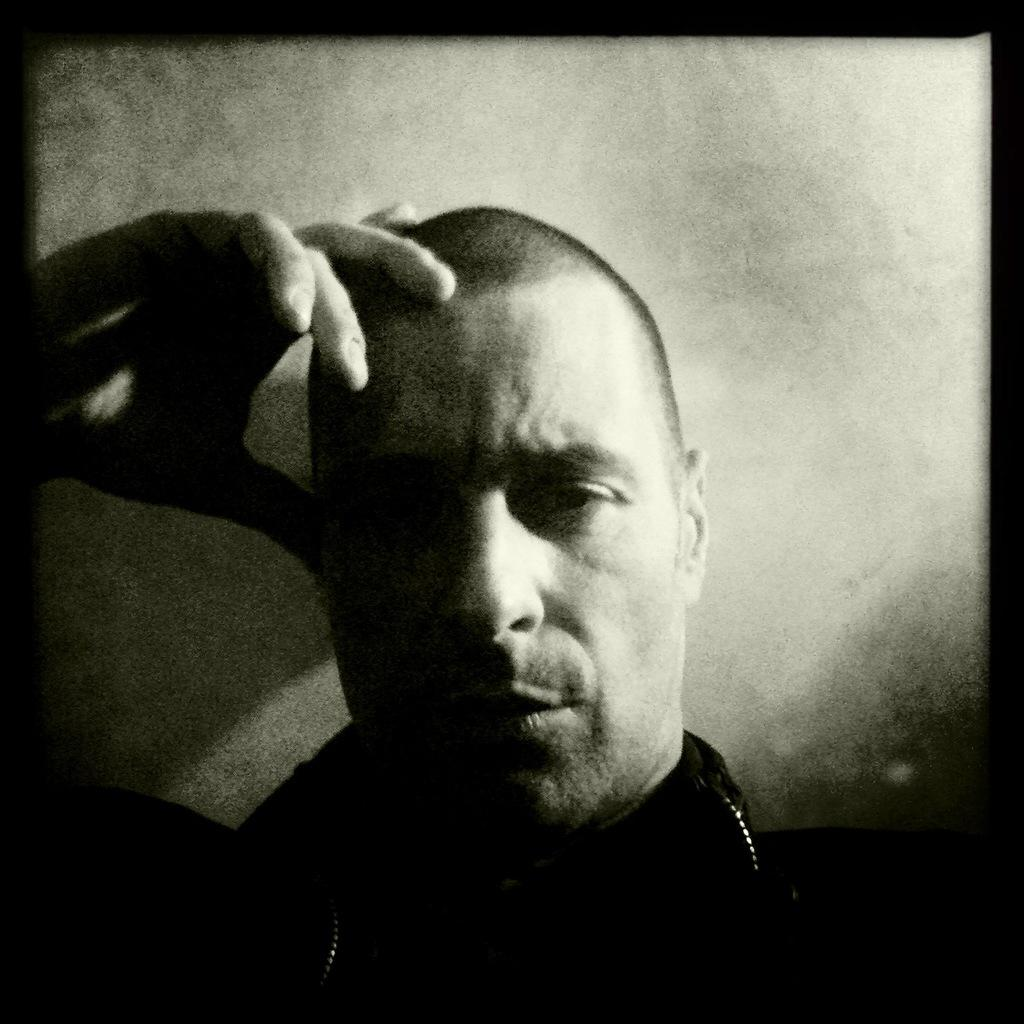Who or what is present in the image? There is a person in the image. What can be seen behind the person? The background of the image is white. What type of property does the person own in the image? There is no information about property ownership in the image. 